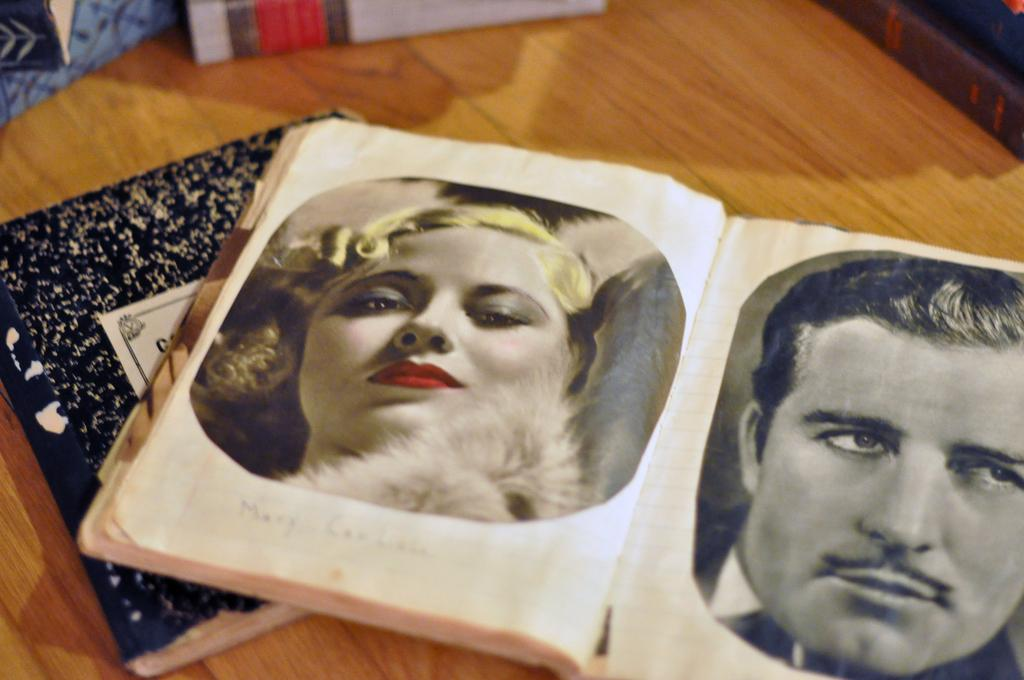What objects are on the table in the image? There are books on a table in the image. What can be seen on one of the books? There are photos of a man and a woman on a book in the image. What type of wire is used to hold the texture of the love in the image? There is no wire or love present in the image; it only features books and photos of a man and a woman. 